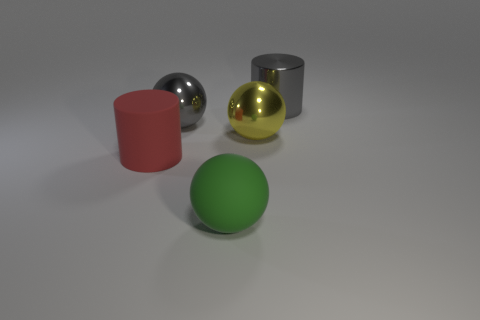What is the shape of the metal object that is the same color as the large shiny cylinder?
Make the answer very short. Sphere. How many other things are there of the same size as the green sphere?
Your answer should be very brief. 4. What shape is the gray shiny object left of the yellow sphere that is behind the green rubber sphere left of the yellow ball?
Offer a very short reply. Sphere. There is a thing that is behind the yellow shiny sphere and to the left of the large metallic cylinder; what shape is it?
Your response must be concise. Sphere. How many things are either metal cylinders or gray metal objects right of the large yellow sphere?
Offer a very short reply. 1. Are the gray cylinder and the big yellow object made of the same material?
Your answer should be very brief. Yes. What number of other objects are the same shape as the red object?
Give a very brief answer. 1. There is a ball that is both behind the green thing and on the left side of the yellow sphere; what size is it?
Give a very brief answer. Large. What number of shiny objects are either big cyan balls or large red cylinders?
Keep it short and to the point. 0. Does the large rubber object behind the green object have the same shape as the big thing that is in front of the red thing?
Provide a succinct answer. No. 